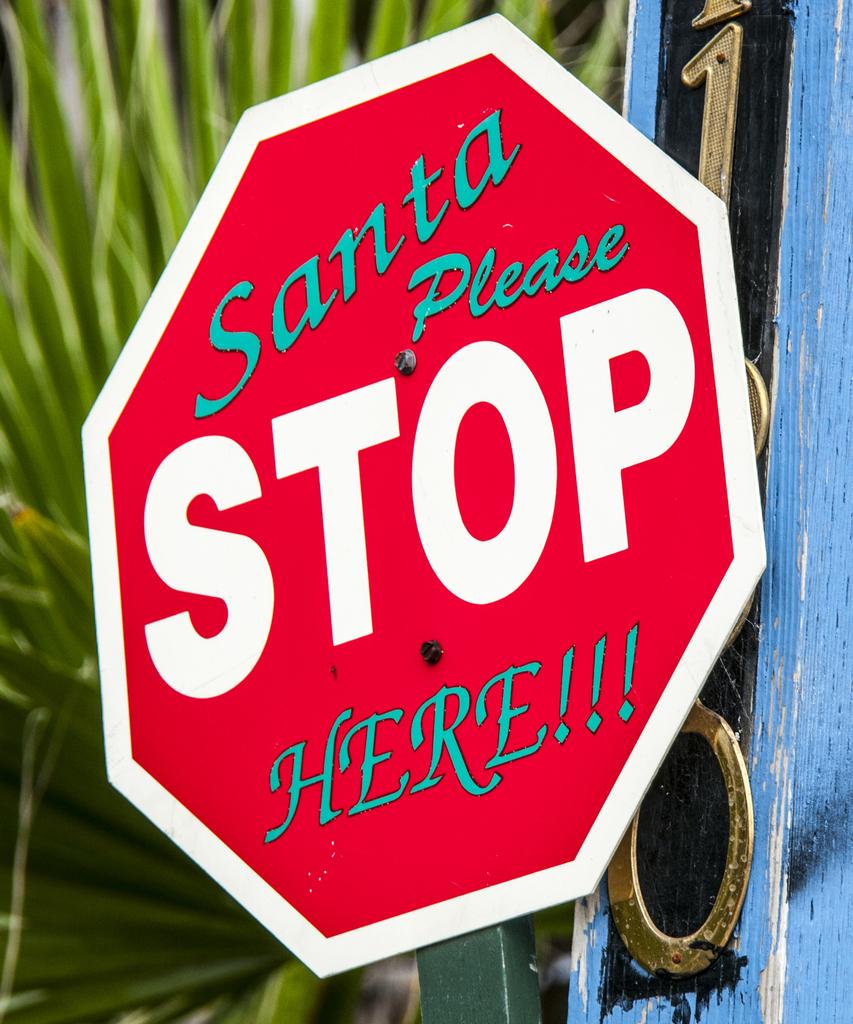Who would stop there?
Give a very brief answer. Santa. How many exclamation points are there?
Give a very brief answer. 3. 